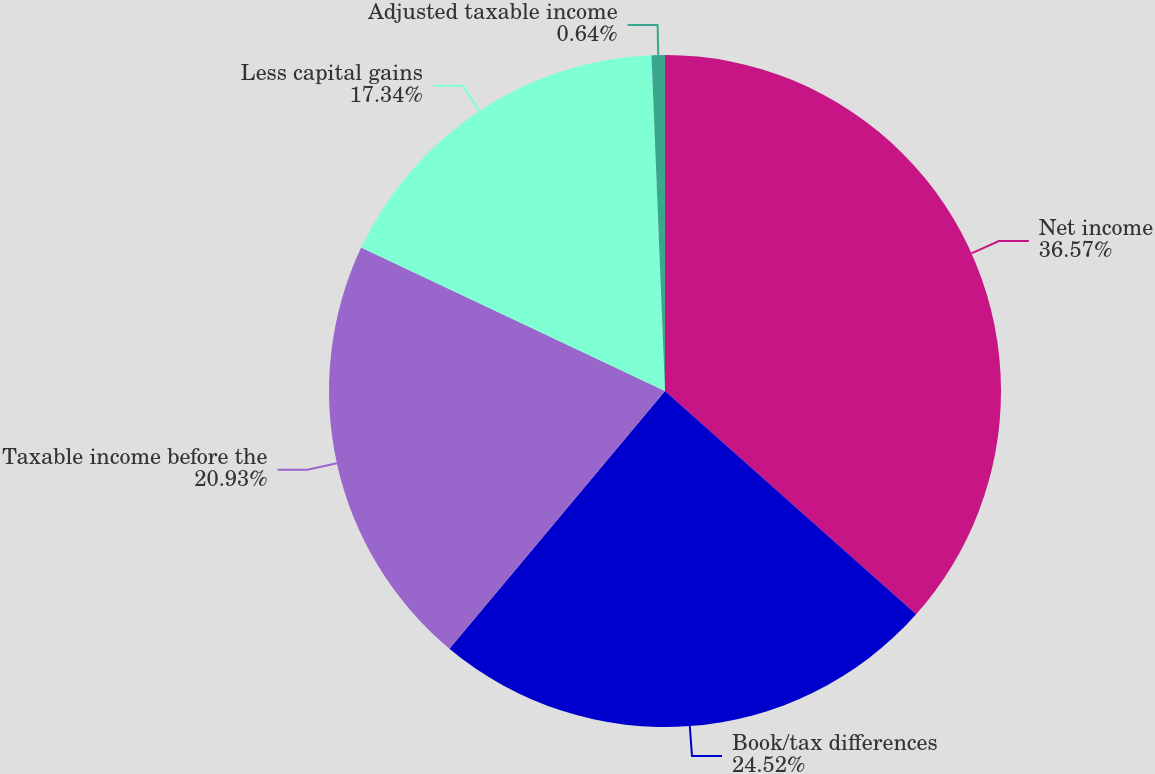Convert chart. <chart><loc_0><loc_0><loc_500><loc_500><pie_chart><fcel>Net income<fcel>Book/tax differences<fcel>Taxable income before the<fcel>Less capital gains<fcel>Adjusted taxable income<nl><fcel>36.56%<fcel>24.52%<fcel>20.93%<fcel>17.34%<fcel>0.64%<nl></chart> 